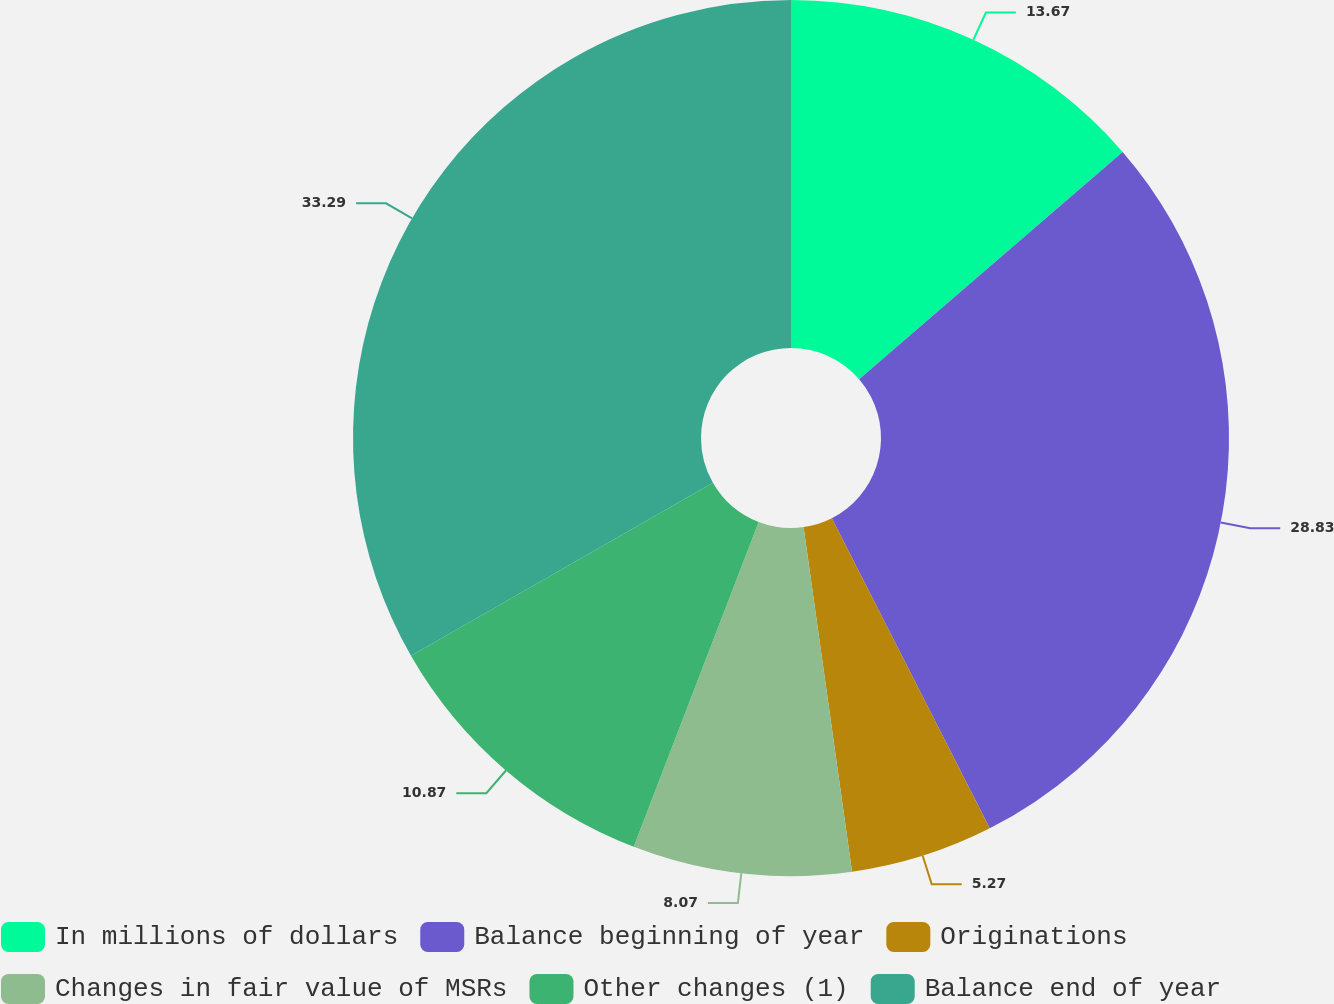<chart> <loc_0><loc_0><loc_500><loc_500><pie_chart><fcel>In millions of dollars<fcel>Balance beginning of year<fcel>Originations<fcel>Changes in fair value of MSRs<fcel>Other changes (1)<fcel>Balance end of year<nl><fcel>13.67%<fcel>28.83%<fcel>5.27%<fcel>8.07%<fcel>10.87%<fcel>33.28%<nl></chart> 